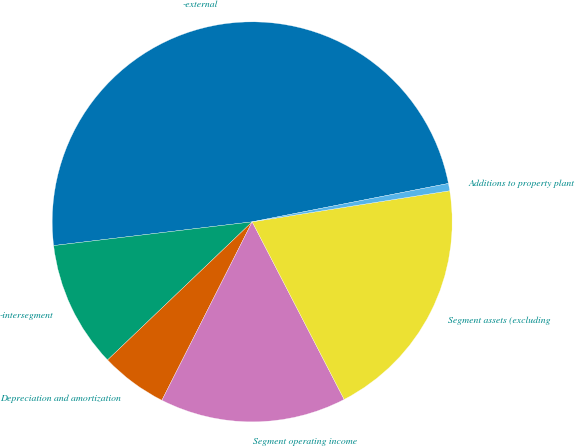<chart> <loc_0><loc_0><loc_500><loc_500><pie_chart><fcel>-external<fcel>-intersegment<fcel>Depreciation and amortization<fcel>Segment operating income<fcel>Segment assets (excluding<fcel>Additions to property plant<nl><fcel>48.82%<fcel>10.24%<fcel>5.41%<fcel>15.06%<fcel>19.88%<fcel>0.59%<nl></chart> 